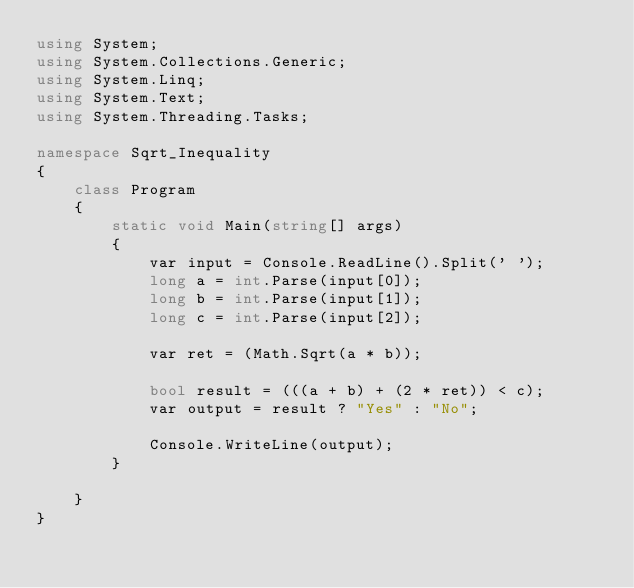<code> <loc_0><loc_0><loc_500><loc_500><_C#_>using System;
using System.Collections.Generic;
using System.Linq;
using System.Text;
using System.Threading.Tasks;

namespace Sqrt_Inequality
{
    class Program
    {
        static void Main(string[] args)
        {
            var input = Console.ReadLine().Split(' ');
            long a = int.Parse(input[0]);
            long b = int.Parse(input[1]);
            long c = int.Parse(input[2]);

            var ret = (Math.Sqrt(a * b));

            bool result = (((a + b) + (2 * ret)) < c);
            var output = result ? "Yes" : "No";

            Console.WriteLine(output);
        }

    }
}
</code> 